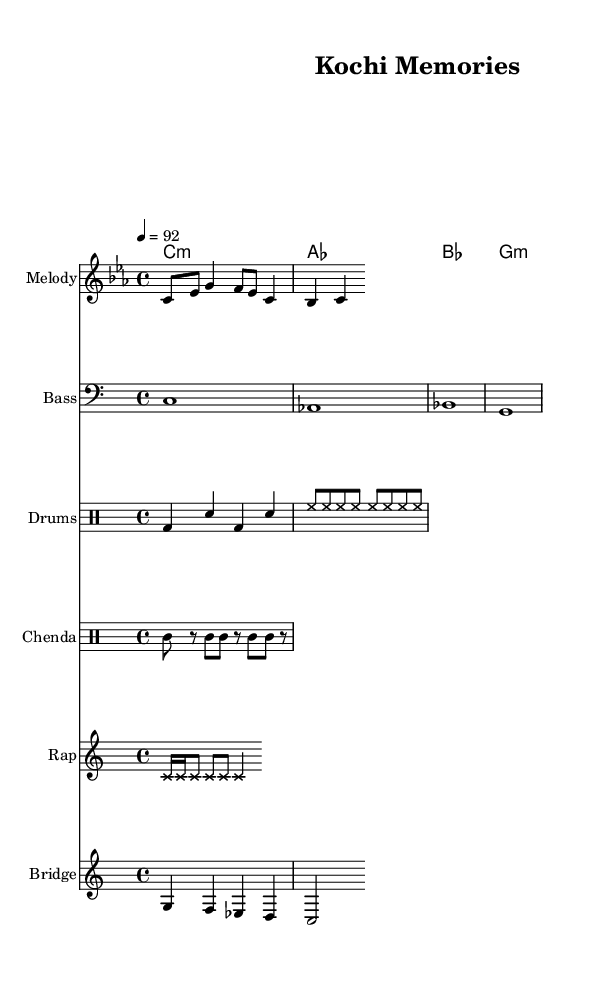What is the key signature of this music? The key signature is C minor, which typically has six flats. In the music, it’s indicated by the `\key c \minor` command.
Answer: C minor What is the time signature of the piece? The time signature shown in the music is 4/4, indicated by the command `\time 4/4`. This means there are four beats in each measure.
Answer: 4/4 What is the tempo marking in this score? The tempo is set at 92 beats per minute, specified by `\tempo 4 = 92`, indicating the speed at which the music should be played.
Answer: 92 How many sections are in the score? The score contains five different sections: Melody, Bass, Drums, Chenda, Rap, and Bridge, as indicated by the staff names in the layout.
Answer: Five What rhythmic element defines the rap section? The rap section is characterized by the use of cross note heads, shown by `\override NoteHead.style = #'cross`, which adds a distinct visual element to indicate the rap's percussive style.
Answer: Cross note heads Which instrument plays the main melodic line? The main melodic line is played by the staff labeled "Melody," where the corresponding notes are represented in the score.
Answer: Melody What type of drums are used in this composition? The score includes two sets of drums: a standard drum set (indicated as "Drums") and a traditional drum (Chenda), providing both a modern and folk rhythm.
Answer: Drums and Chenda 